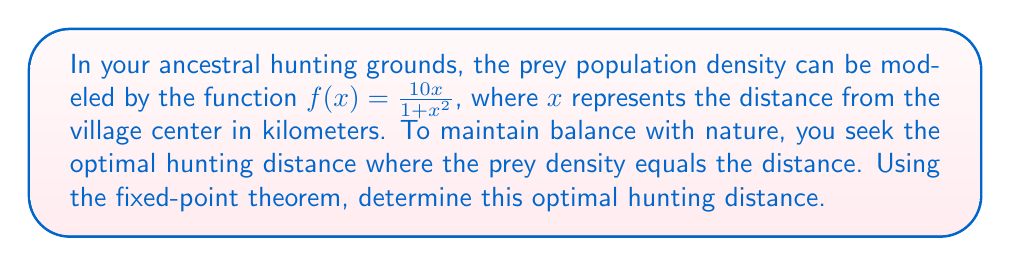Help me with this question. To solve this problem, we'll use the fixed-point theorem and follow these steps:

1) The optimal hunting distance occurs when $f(x) = x$. This is a fixed point of the function.

2) Set up the equation:
   $$\frac{10x}{1+x^2} = x$$

3) Multiply both sides by $(1+x^2)$:
   $$10x = x(1+x^2)$$

4) Expand the right side:
   $$10x = x + x^3$$

5) Subtract $x$ from both sides:
   $$9x = x^3$$

6) Rearrange to standard form:
   $$x^3 - 9x = 0$$

7) Factor out $x$:
   $$x(x^2 - 9) = 0$$

8) Further factoring:
   $$x(x+3)(x-3) = 0$$

9) Solve for $x$:
   $x = 0$, $x = -3$, or $x = 3$

10) Since distance can't be negative and $x = 0$ doesn't satisfy the original equation, the only valid solution is $x = 3$.

11) Verify by plugging back into the original function:
    $$f(3) = \frac{10(3)}{1+3^2} = \frac{30}{10} = 3$$

Therefore, the fixed point and optimal hunting distance is 3 kilometers from the village center.
Answer: 3 km 